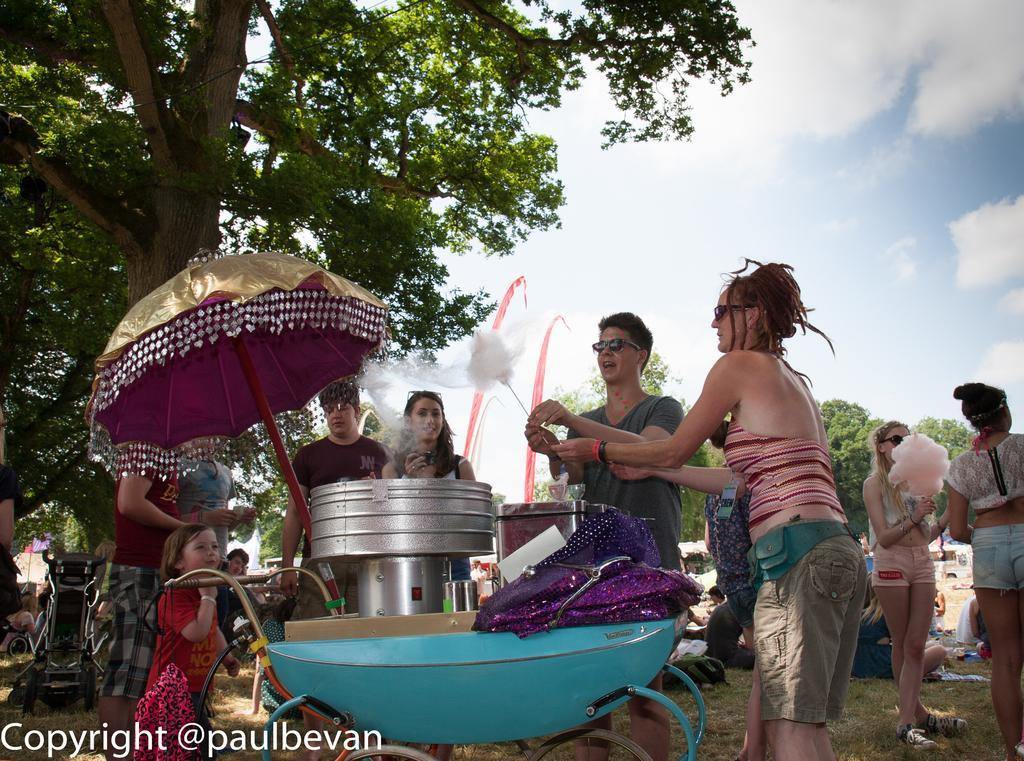Could you give a brief overview of what you see in this image? In this picture we can see a group of people on the ground, some people are sitting and some people are standing and two people are holding sugar candies, here we can see an umbrella, bowls, clothes and some objects and in the background we can see trees and sky with clouds, in the bottom left we can see some text on it. 